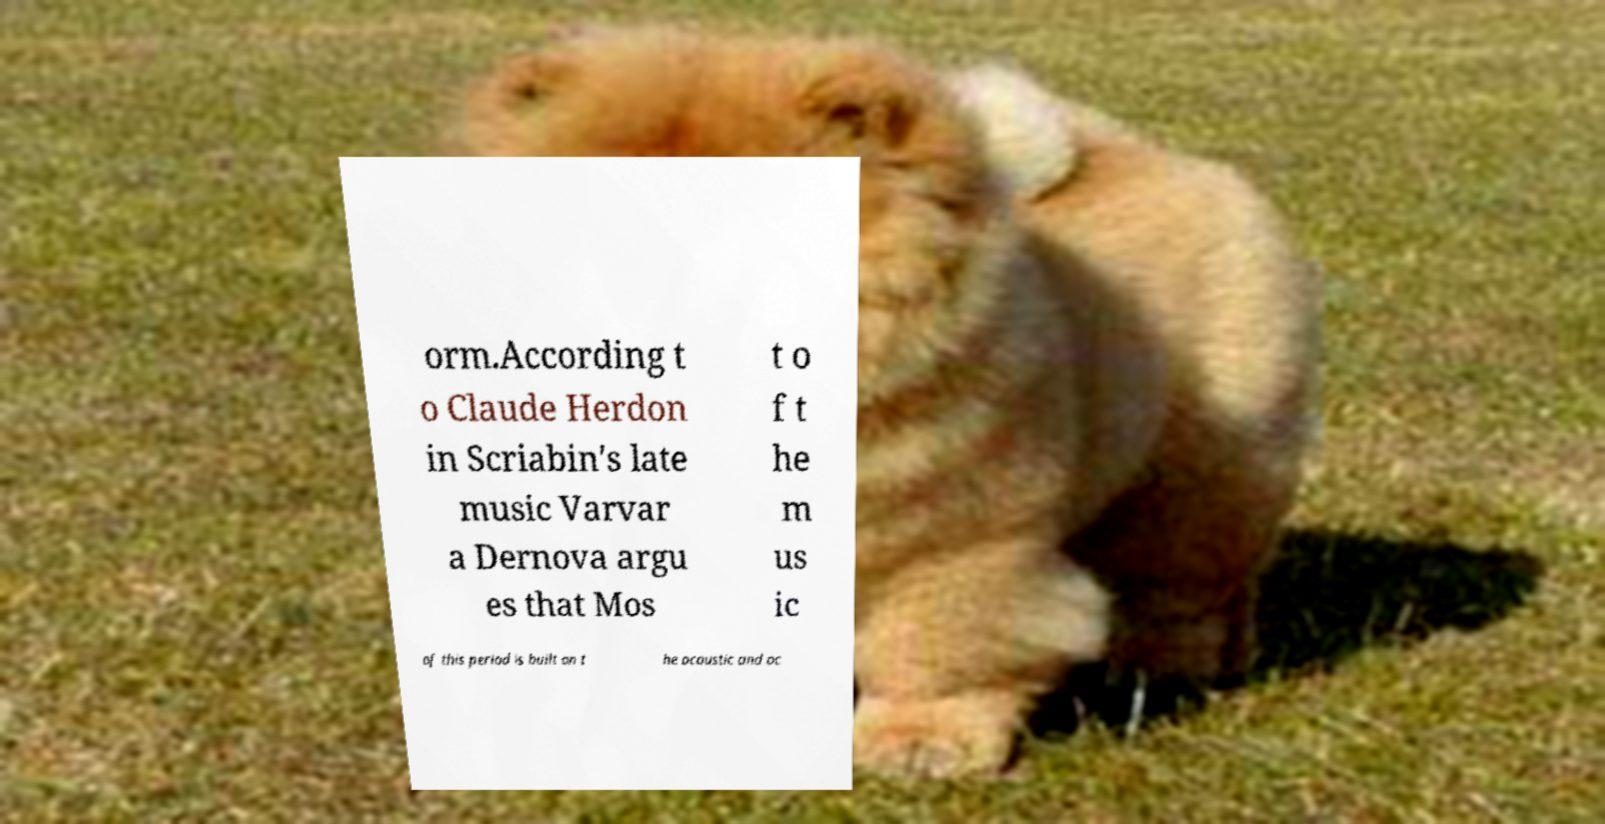Could you assist in decoding the text presented in this image and type it out clearly? orm.According t o Claude Herdon in Scriabin's late music Varvar a Dernova argu es that Mos t o f t he m us ic of this period is built on t he acoustic and oc 